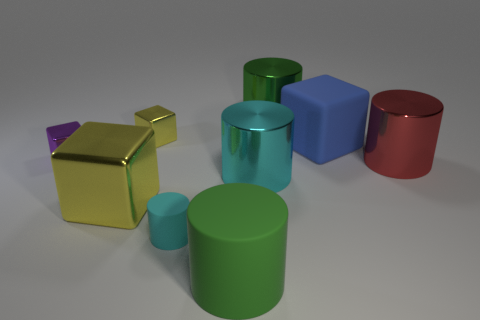Subtract all blue blocks. How many blocks are left? 3 Subtract all yellow blocks. How many blocks are left? 2 Add 1 cyan things. How many objects exist? 10 Subtract 0 purple cylinders. How many objects are left? 9 Subtract all cylinders. How many objects are left? 4 Subtract 3 blocks. How many blocks are left? 1 Subtract all green cubes. Subtract all blue spheres. How many cubes are left? 4 Subtract all green blocks. How many red cylinders are left? 1 Subtract all large cyan objects. Subtract all green metallic cylinders. How many objects are left? 7 Add 5 big metallic objects. How many big metallic objects are left? 9 